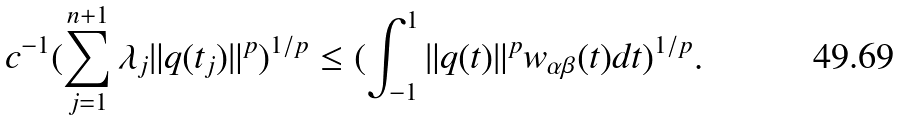Convert formula to latex. <formula><loc_0><loc_0><loc_500><loc_500>c ^ { - 1 } ( \sum _ { j = 1 } ^ { n + 1 } \lambda _ { j } \| q ( t _ { j } ) \| ^ { p } ) ^ { 1 / p } \leq ( \int ^ { 1 } _ { - 1 } \| q ( t ) \| ^ { p } w _ { \alpha \beta } ( t ) d t ) ^ { 1 / p } .</formula> 